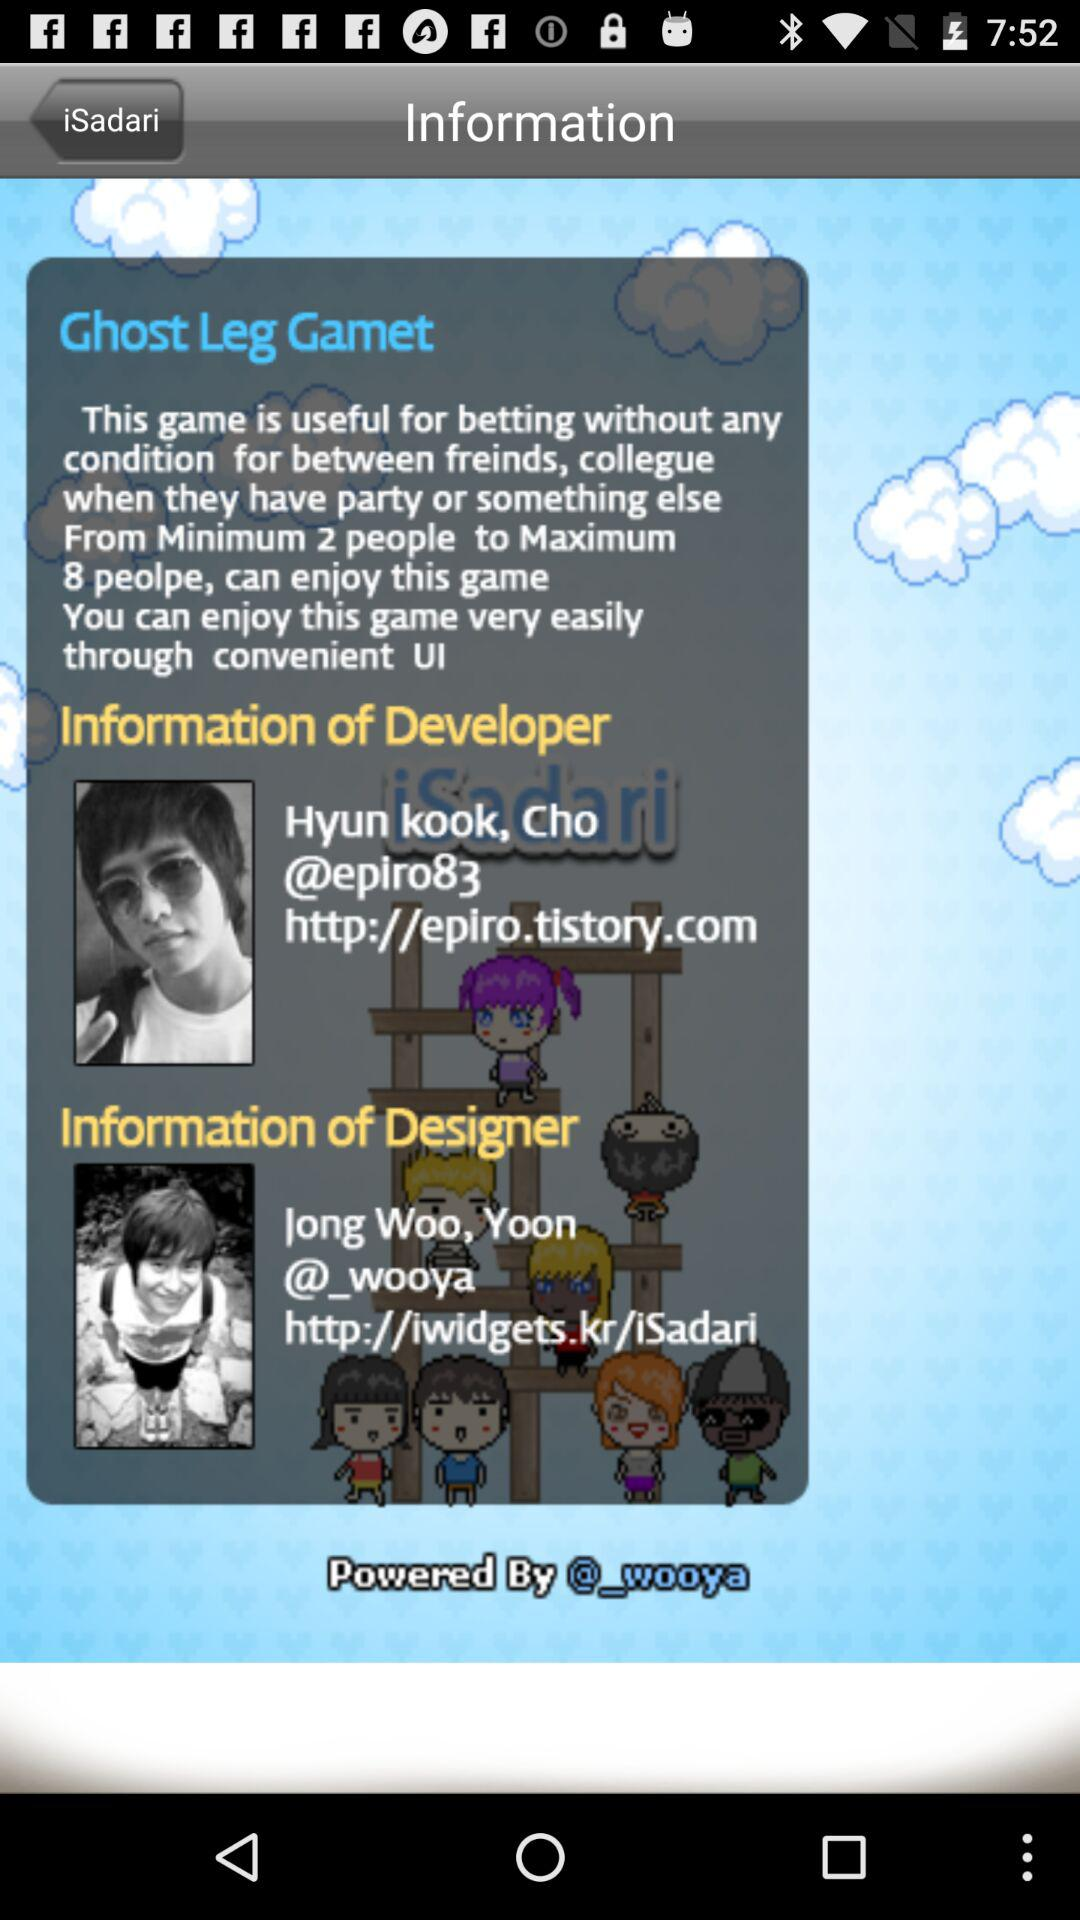How many people can play this game at its maximum and minimum? A maximum of 8 people and a minimum of 2 people can play this game. 